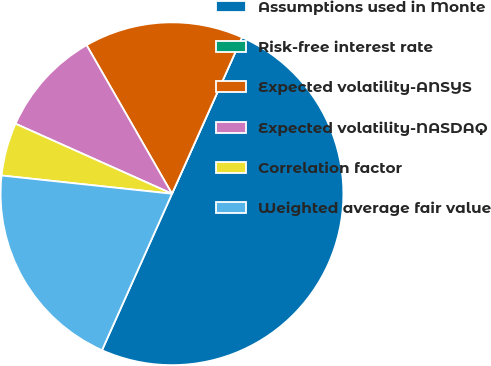<chart> <loc_0><loc_0><loc_500><loc_500><pie_chart><fcel>Assumptions used in Monte<fcel>Risk-free interest rate<fcel>Expected volatility-ANSYS<fcel>Expected volatility-NASDAQ<fcel>Correlation factor<fcel>Weighted average fair value<nl><fcel>49.99%<fcel>0.0%<fcel>15.0%<fcel>10.0%<fcel>5.0%<fcel>20.0%<nl></chart> 